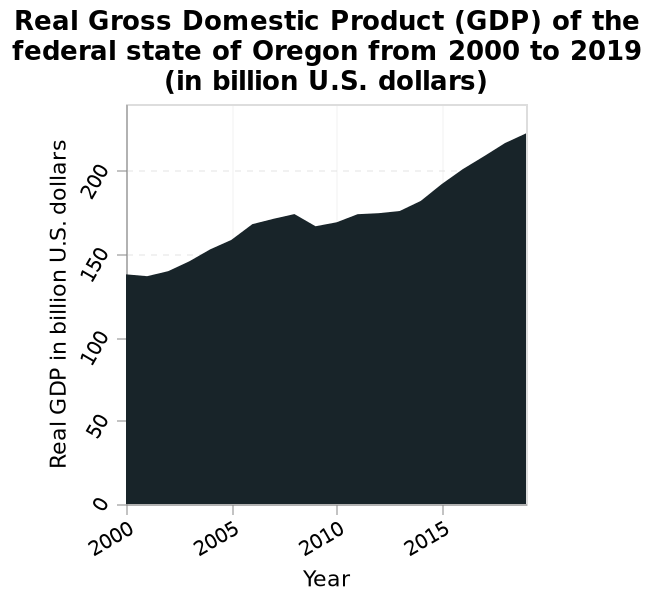<image>
please enumerates aspects of the construction of the chart Real Gross Domestic Product (GDP) of the federal state of Oregon from 2000 to 2019 (in billion U.S. dollars) is a area graph. The x-axis shows Year as linear scale from 2000 to 2015 while the y-axis measures Real GDP in billion U.S. dollars as linear scale with a minimum of 0 and a maximum of 200. 